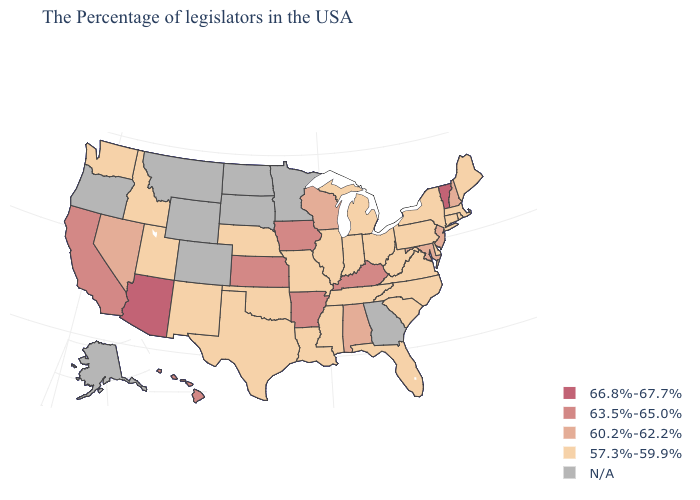What is the value of Oklahoma?
Write a very short answer. 57.3%-59.9%. Which states have the highest value in the USA?
Concise answer only. Vermont, Arizona. What is the value of Washington?
Write a very short answer. 57.3%-59.9%. Name the states that have a value in the range 57.3%-59.9%?
Give a very brief answer. Maine, Massachusetts, Rhode Island, Connecticut, New York, Delaware, Pennsylvania, Virginia, North Carolina, South Carolina, West Virginia, Ohio, Florida, Michigan, Indiana, Tennessee, Illinois, Mississippi, Louisiana, Missouri, Nebraska, Oklahoma, Texas, New Mexico, Utah, Idaho, Washington. What is the highest value in states that border New Jersey?
Write a very short answer. 57.3%-59.9%. Name the states that have a value in the range N/A?
Give a very brief answer. Georgia, Minnesota, South Dakota, North Dakota, Wyoming, Colorado, Montana, Oregon, Alaska. What is the value of Maryland?
Answer briefly. 60.2%-62.2%. What is the value of New Mexico?
Short answer required. 57.3%-59.9%. Name the states that have a value in the range N/A?
Concise answer only. Georgia, Minnesota, South Dakota, North Dakota, Wyoming, Colorado, Montana, Oregon, Alaska. How many symbols are there in the legend?
Write a very short answer. 5. Does Florida have the lowest value in the USA?
Answer briefly. Yes. What is the highest value in states that border Michigan?
Quick response, please. 60.2%-62.2%. Which states have the lowest value in the USA?
Answer briefly. Maine, Massachusetts, Rhode Island, Connecticut, New York, Delaware, Pennsylvania, Virginia, North Carolina, South Carolina, West Virginia, Ohio, Florida, Michigan, Indiana, Tennessee, Illinois, Mississippi, Louisiana, Missouri, Nebraska, Oklahoma, Texas, New Mexico, Utah, Idaho, Washington. 